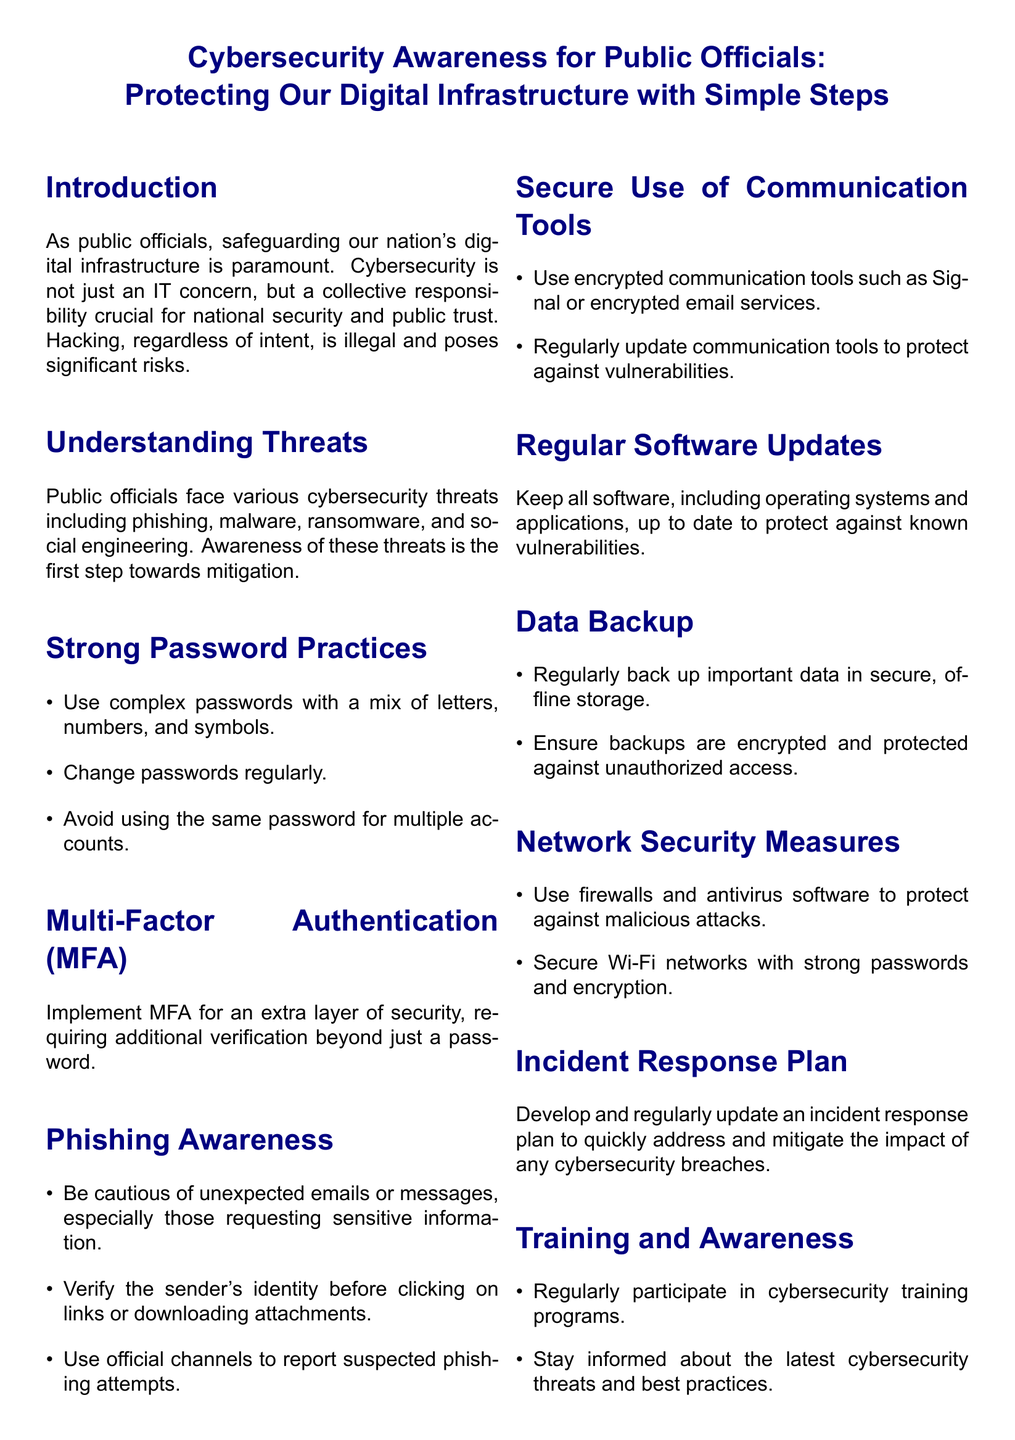What is the main focus of the flyer? The main focus is on safeguarding the nation's digital infrastructure through cybersecurity awareness for public officials.
Answer: Safeguarding our nation's digital infrastructure What type of security measure is recommended for extra protection? The flyer suggests Multi-Factor Authentication as an extra layer of security beyond just a password.
Answer: Multi-Factor Authentication Which item should be regularly updated according to the flyer? The document states that all software, including operating systems and applications, should be kept up to date.
Answer: Software What should public officials be cautious of to prevent security breaches? The flyer advises officials to be cautious of unexpected emails or messages that request sensitive information.
Answer: Unexpected emails or messages How should data backups be stored according to the flyer? Backups should be stored in secure, offline storage and ensured to be encrypted and protected against unauthorized access.
Answer: Secure offline storage What is the purpose of the incident response plan mentioned? The incident response plan is meant to quickly address and mitigate the impact of any cybersecurity breaches.
Answer: Mitigate impact of breaches What type of tools should be used for secure communication? The flyer recommends using encrypted communication tools like Signal or encrypted email services.
Answer: Encrypted communication tools How often should public officials participate in cybersecurity training programs? The document suggests that public officials should regularly participate in cybersecurity training programs.
Answer: Regularly What color scheme is used in the flyer? The color scheme features navy and light blue for the text and background elements, respectively.
Answer: Navy and light blue 